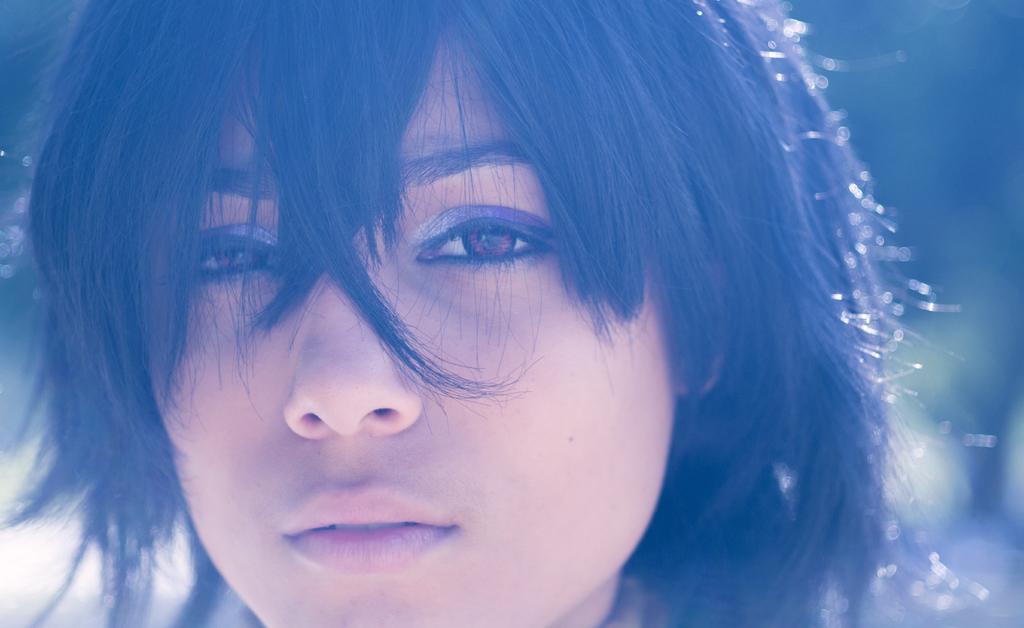How would you summarize this image in a sentence or two? We can see woman face and hair. In the background it is blur. 